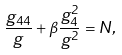<formula> <loc_0><loc_0><loc_500><loc_500>\frac { g _ { 4 4 } } { g } + \beta \frac { g ^ { 2 } _ { 4 } } { g ^ { 2 } } = N ,</formula> 